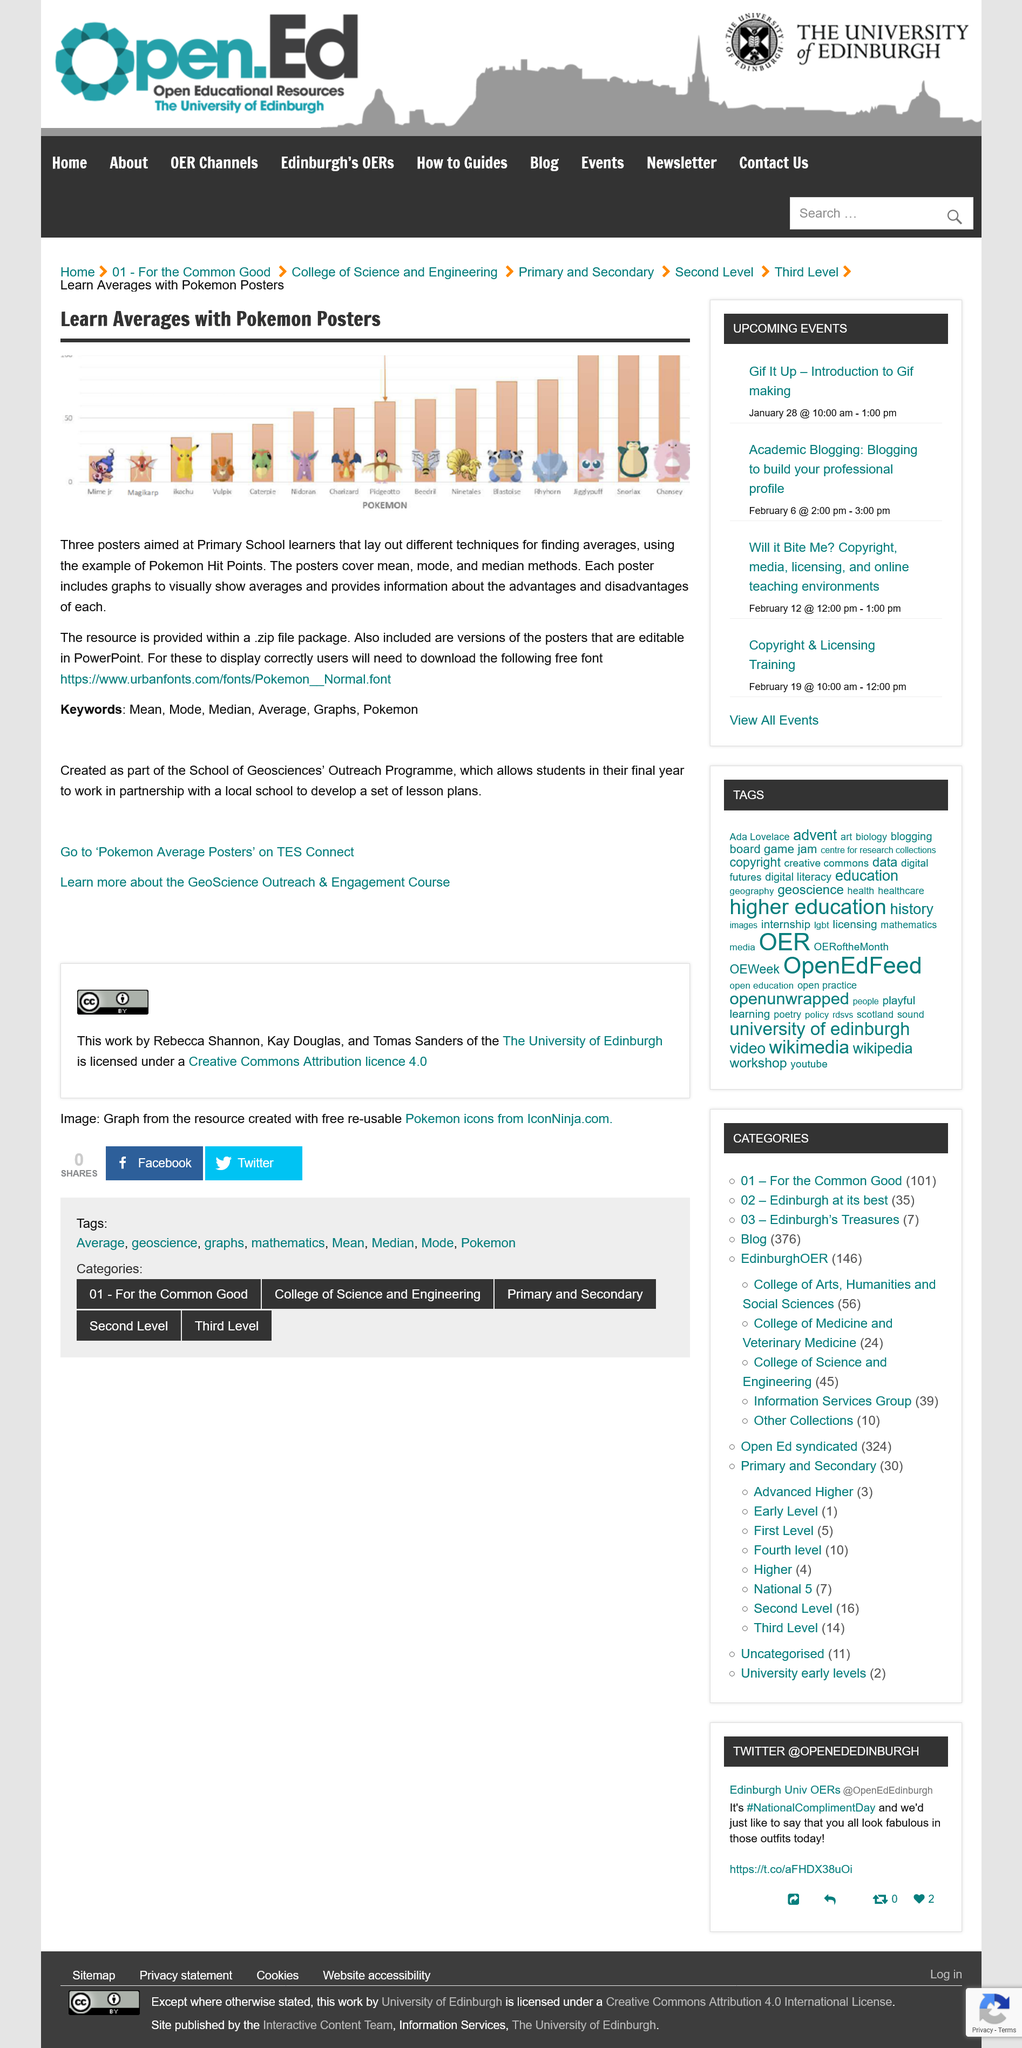Highlight a few significant elements in this photo. The Pokemon posters cover the average measures of central tendency, which include mean, mode, and median. The Pokemon poster is intended for Primary School learners. The bars on Pokemon posters represent the Pokemon's Hit Points. 